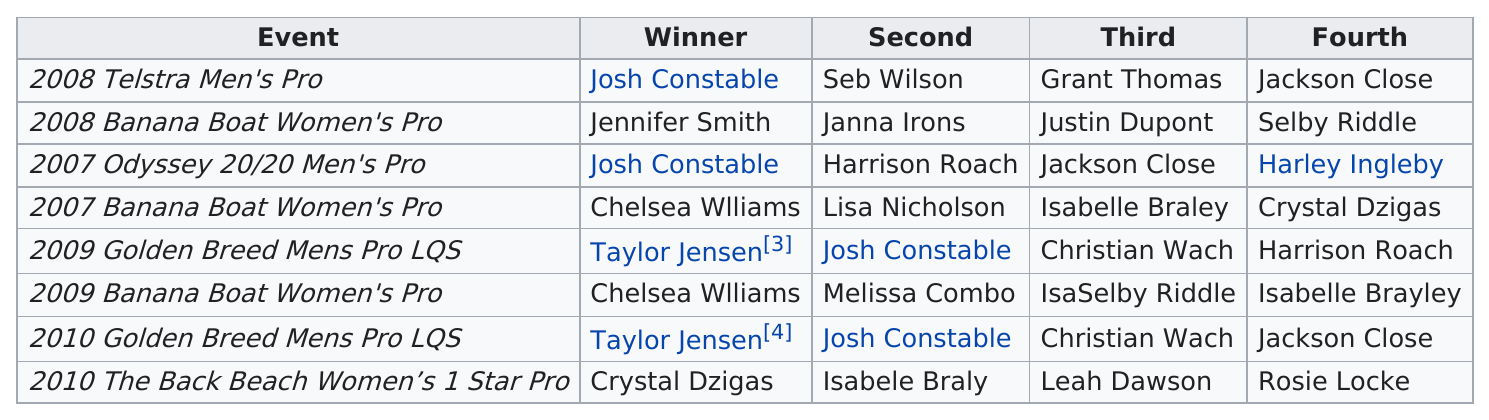Give some essential details in this illustration. Seb Wilson was the next person to finish after Josh Constable in the 2008 Telstra Men's Pro competition. In 2007, Chelsea Williams won her first professional surfing title at the Banana Boat Women's Pro competition. In the given sentence, "did" is the linking verb that connects the subject "jackson" to the predicate adjective "close" and the object "rank" which modifies the adjective "fourth". The word "how" is used to make a question and "many" is used to indicate a quantity. Therefore, the sentence can be restated as:

Jackson closed rank fourth a total of 2 times. Josh Constable came in second on two occasions. In the 2008 Telstra Men's Pro, Josh Constable performed better than in the 2009 Golden Breed Men's Pro LQS. 